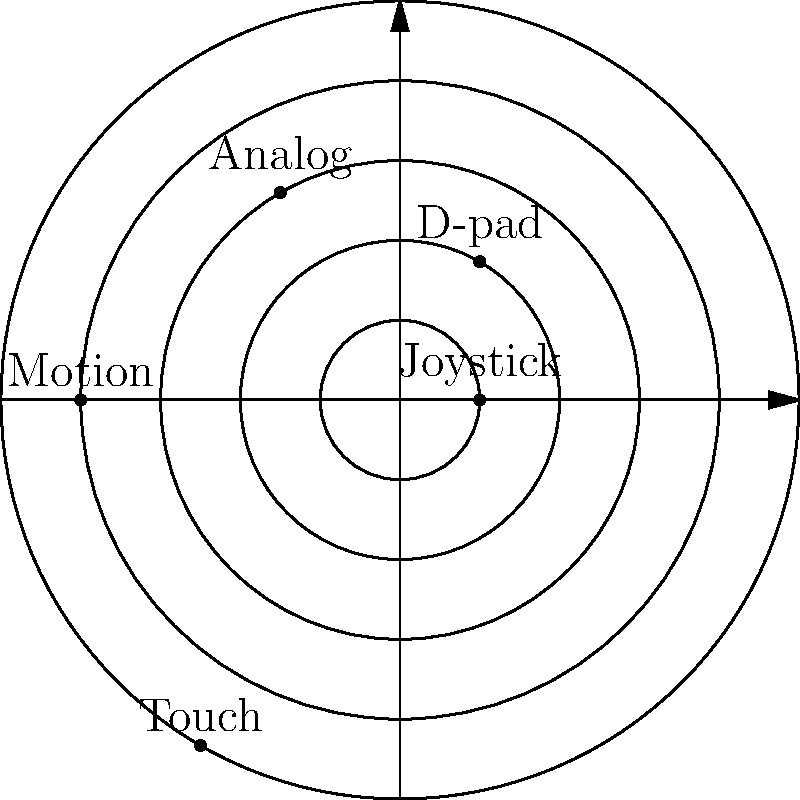In the polar coordinate graph representing the evolution of video game controllers, which type of controller is positioned at $(r, \theta) = (4, \pi)$? To answer this question, we need to follow these steps:

1. Understand the graph:
   - The graph uses polar coordinates $(r, \theta)$ to map different types of controllers.
   - $r$ represents the distance from the origin (evolution over time).
   - $\theta$ represents the angle from the positive x-axis (measured counterclockwise).

2. Identify the given coordinates:
   - We're looking for the point at $(r, \theta) = (4, \pi)$.

3. Interpret the coordinates:
   - $r = 4$ means we're looking at the 4th circle from the center.
   - $\theta = \pi$ means we're looking at the point on the negative x-axis (180 degrees).

4. Locate the point on the graph:
   - Moving to the 4th circle and then to the leftmost point on that circle.

5. Identify the controller type at that point:
   - The label at $(4, \pi)$ is "Motion".

Therefore, the controller type positioned at $(r, \theta) = (4, \pi)$ is the Motion controller.
Answer: Motion controller 